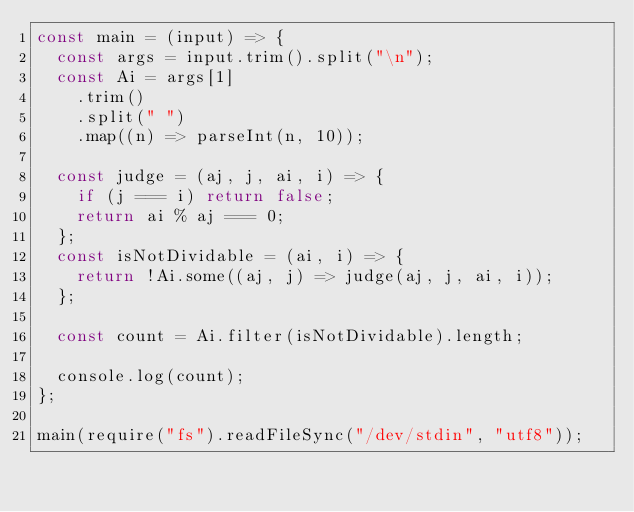Convert code to text. <code><loc_0><loc_0><loc_500><loc_500><_JavaScript_>const main = (input) => {
  const args = input.trim().split("\n");
  const Ai = args[1]
    .trim()
    .split(" ")
    .map((n) => parseInt(n, 10));

  const judge = (aj, j, ai, i) => {
    if (j === i) return false;
    return ai % aj === 0;
  };
  const isNotDividable = (ai, i) => {
    return !Ai.some((aj, j) => judge(aj, j, ai, i));
  };

  const count = Ai.filter(isNotDividable).length;

  console.log(count);
};

main(require("fs").readFileSync("/dev/stdin", "utf8"));</code> 